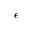Convert formula to latex. <formula><loc_0><loc_0><loc_500><loc_500>\epsilon</formula> 